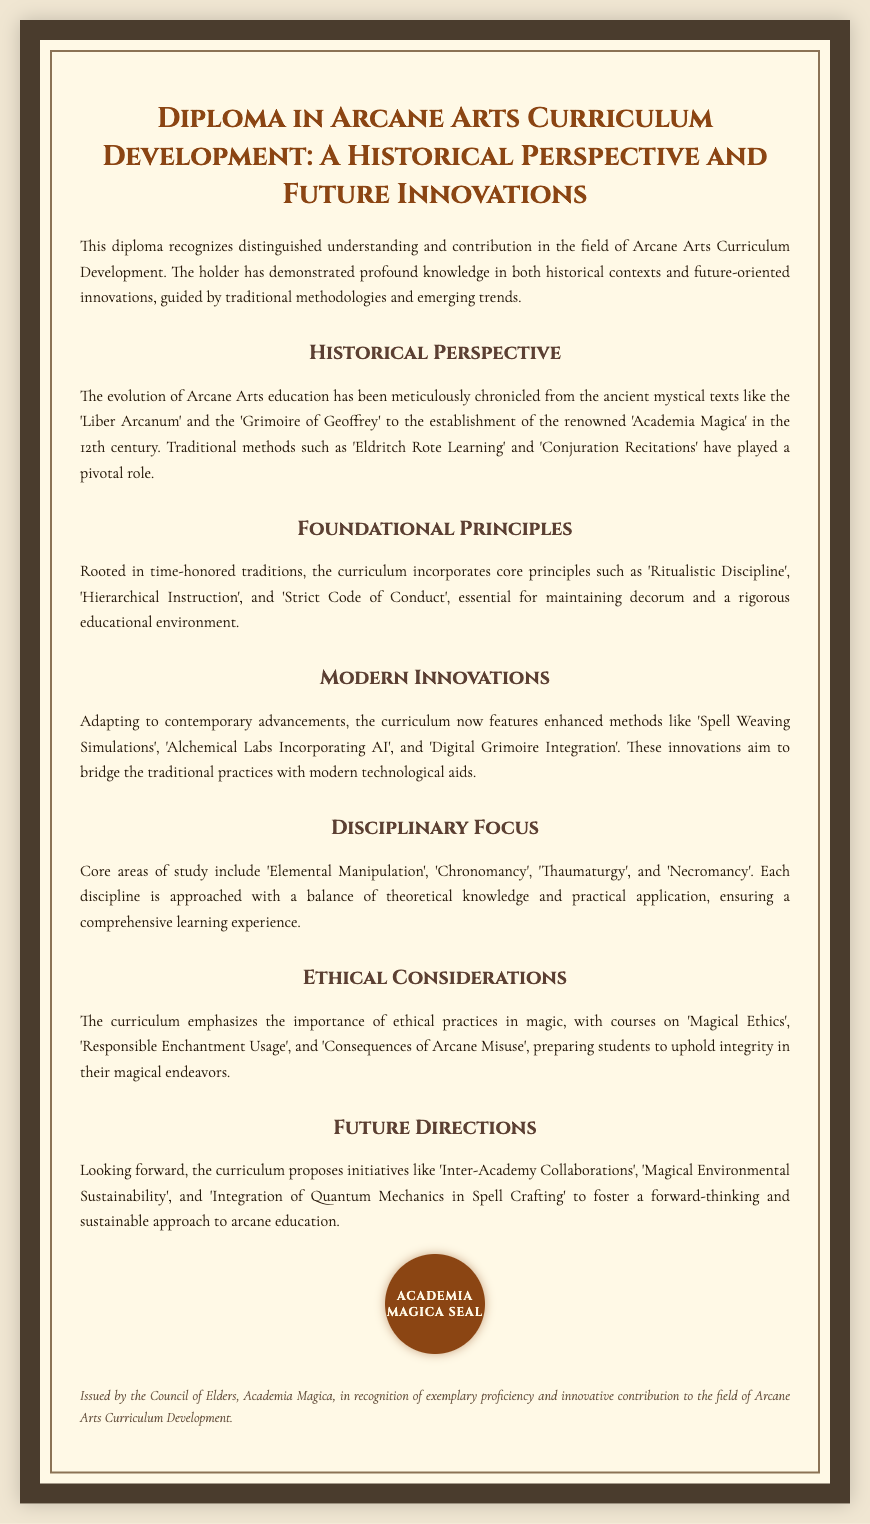what is the title of the diploma? The title of the diploma is prominently displayed at the top of the document, stating its full name.
Answer: Diploma in Arcane Arts Curriculum Development: A Historical Perspective and Future Innovations which century was the 'Academia Magica' established? The document specifies the time period during which 'Academia Magica' was founded, indicating it is a significant historical landmark in Arcane Arts education.
Answer: 12th century what is one of the core principles of the curriculum? The document mentions key foundational principles that guide the curriculum, highlighting its grounding in tradition.
Answer: Ritualistic Discipline name a modern innovation included in the curriculum. The document outlines various advancements integrated into the curriculum, showcasing contemporary approaches to Arcane Arts education.
Answer: Spell Weaving Simulations what area of study includes 'Chronomancy'? The document identifies core disciplines within the curriculum and associates them with their respective theoretical and practical components.
Answer: Disciplinary Focus what does the curriculum emphasize regarding ethical practices? The document highlights the importance of ethics in the practice of magic, indicating specific courses designed to educate students on this matter.
Answer: Ethical Considerations which future initiative focuses on environmental sustainability? The document discusses future initiatives aimed at improving Arcane education and ensuring its relevance and responsibility toward society.
Answer: Magical Environmental Sustainability what institution issued the diploma? The document provides information regarding the authority behind the diploma, reflecting its credibility and recognition in the field.
Answer: Council of Elders, Academia Magica 